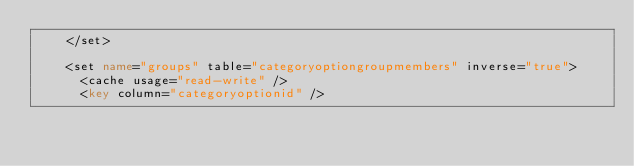Convert code to text. <code><loc_0><loc_0><loc_500><loc_500><_XML_>    </set>

    <set name="groups" table="categoryoptiongroupmembers" inverse="true">
      <cache usage="read-write" />
      <key column="categoryoptionid" /></code> 